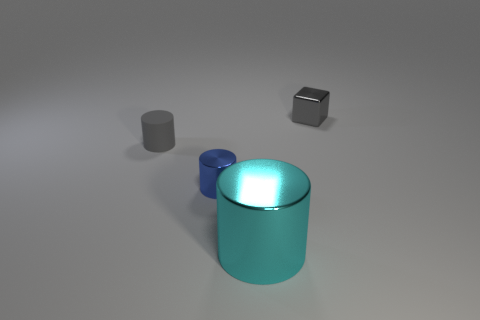How many other objects are there of the same shape as the tiny blue metal thing?
Make the answer very short. 2. There is a metallic object that is in front of the tiny metallic thing that is in front of the gray shiny block; what size is it?
Keep it short and to the point. Large. Are there any big purple shiny cylinders?
Offer a very short reply. No. There is a small gray object that is on the right side of the tiny rubber object; what number of tiny blue cylinders are in front of it?
Offer a very short reply. 1. There is a tiny object on the right side of the big cyan metal cylinder; what is its shape?
Your answer should be very brief. Cube. What is the material of the small gray object that is left of the small metal thing that is in front of the gray metal block behind the tiny blue shiny cylinder?
Keep it short and to the point. Rubber. What number of other objects are there of the same size as the metal cube?
Offer a terse response. 2. What material is the other tiny object that is the same shape as the tiny blue metal thing?
Provide a short and direct response. Rubber. The metallic block has what color?
Offer a terse response. Gray. The tiny shiny thing that is behind the small gray object that is in front of the tiny gray block is what color?
Provide a succinct answer. Gray. 